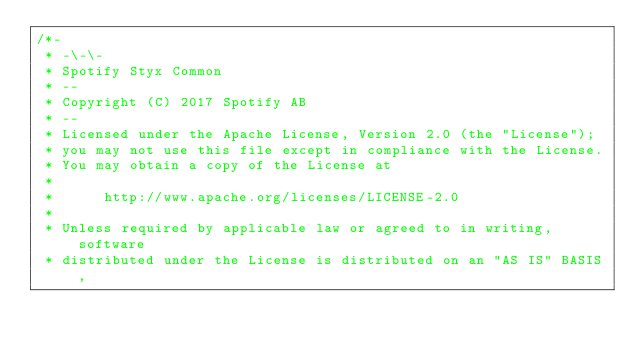<code> <loc_0><loc_0><loc_500><loc_500><_Java_>/*-
 * -\-\-
 * Spotify Styx Common
 * --
 * Copyright (C) 2017 Spotify AB
 * --
 * Licensed under the Apache License, Version 2.0 (the "License");
 * you may not use this file except in compliance with the License.
 * You may obtain a copy of the License at
 * 
 *      http://www.apache.org/licenses/LICENSE-2.0
 * 
 * Unless required by applicable law or agreed to in writing, software
 * distributed under the License is distributed on an "AS IS" BASIS,</code> 